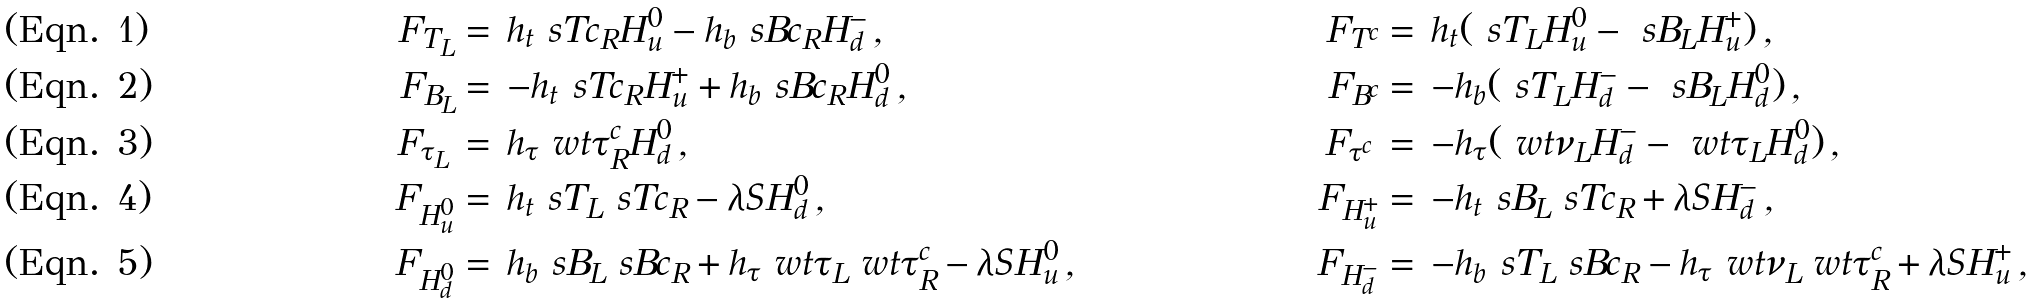<formula> <loc_0><loc_0><loc_500><loc_500>F _ { T _ { L } } & = \, h _ { t } \ s T c _ { R } H ^ { 0 } _ { u } - h _ { b } \ s B c _ { R } H ^ { - } _ { d } \, , & F _ { T ^ { c } } & = \, h _ { t } ( \ s T _ { L } H ^ { 0 } _ { u } - \ s B _ { L } H ^ { + } _ { u } ) \, , \\ F _ { B _ { L } } & = \, - h _ { t } \ s T c _ { R } H ^ { + } _ { u } + h _ { b } \ s B c _ { R } H ^ { 0 } _ { d } \, , & F _ { B ^ { c } } & = \, - h _ { b } ( \ s T _ { L } H ^ { - } _ { d } - \ s B _ { L } H ^ { 0 } _ { d } ) \, , \\ F _ { \tau _ { L } } \, & = \, h _ { \tau } \ w t \tau ^ { c } _ { R } H ^ { 0 } _ { d } \, , & F _ { \tau ^ { c } } \, & = \, - h _ { \tau } ( \ w t \nu _ { L } H ^ { - } _ { d } - \ w t \tau _ { L } H ^ { 0 } _ { d } ) \, , \\ F _ { H ^ { 0 } _ { u } } & = \, h _ { t } \ s T _ { L } \ s T c _ { R } - \lambda S H ^ { 0 } _ { d } \, , & F _ { H ^ { + } _ { u } } & = \, - h _ { t } \ s B _ { L } \ s T c _ { R } + \lambda S H ^ { - } _ { d } \, , \\ F _ { H ^ { 0 } _ { d } } & = \, h _ { b } \ s B _ { L } \ s B c _ { R } + h _ { \tau } \ w t \tau _ { L } \ w t \tau ^ { c } _ { R } - \lambda S H ^ { 0 } _ { u } \, , & F _ { H ^ { - } _ { d } } & = \, - h _ { b } \ s T _ { L } \ s B c _ { R } - h _ { \tau } \ w t \nu _ { L } \ w t \tau ^ { c } _ { R } + \lambda S H ^ { + } _ { u } \, ,</formula> 